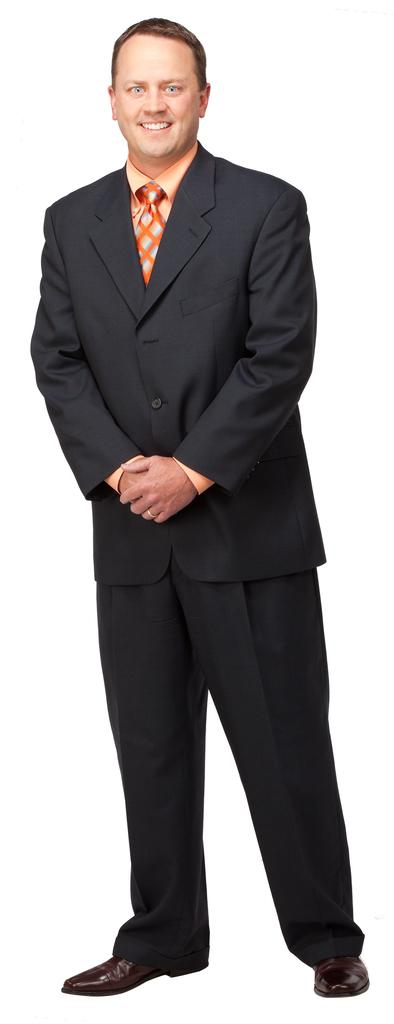What is the main subject of the image? There is a person in the image. What is the person's facial expression? The person is smiling. What color is the background of the image? The background of the image is white. What type of skirt is the fish wearing in the image? There is no fish or skirt present in the image; it features a person with a white background. 